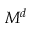Convert formula to latex. <formula><loc_0><loc_0><loc_500><loc_500>M ^ { d }</formula> 